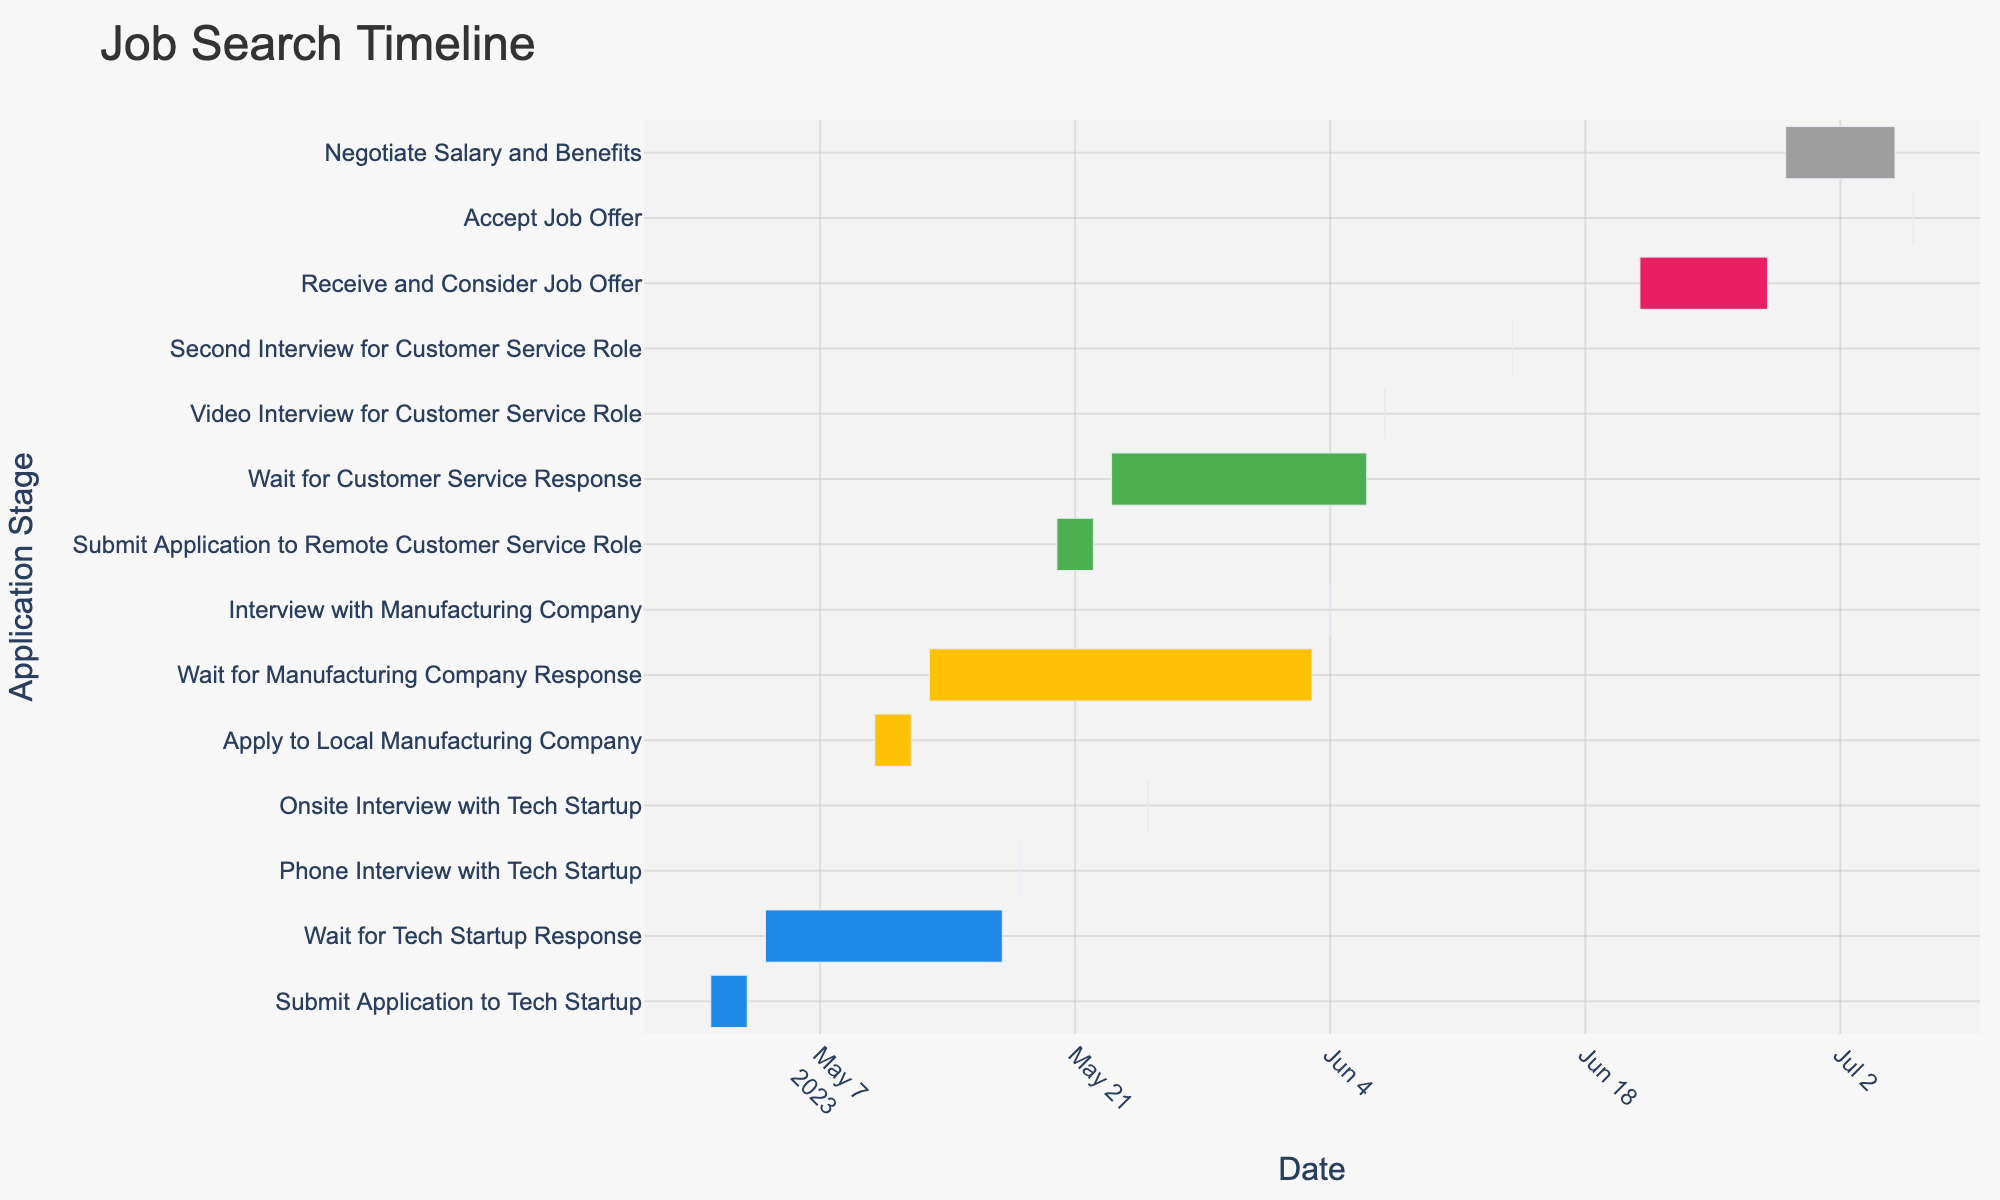What's the title of the figure? The title is usually located at the top of the figure. In this case, it is "Job Search Timeline."
Answer: Job Search Timeline What are the different job types represented in the figure? The job types can be inferred from the color legend and the tasks related to different industries. They are "Tech Startup," "Manufacturing Company," "Customer Service," and "Job Offer."
Answer: Tech Startup, Manufacturing Company, Customer Service, Job Offer How long did you wait for a response from the Tech Startup after applying? Look at the "Tech Startup" related tasks. The waiting period is from "2023-05-04" to "2023-05-17." Subtracting the start date from the end date gives 13 days.
Answer: 13 days Which job type had the most interview stages? Compare the interview stages for each job type. Customer Service has two interview stages: "Video Interview" and "Second Interview."
Answer: Customer Service What is the duration from the end of the application to receiving a response for the Remote Customer Service Role? For Customer Service, the application ends on "2023-05-22," and the response wait ends on "2023-06-06." Subtract the application end date from the response wait end date to get 15 days.
Answer: 15 days When did you have the onsite interview with the Tech Startup? Look for the "Onsite Interview with Tech Startup" task, which occurs on "2023-05-25."
Answer: 2023-05-25 How long did the entire job search process take, from the first application to accepting the job offer? The first application started on "2023-05-01," and the job offer was accepted on "2023-07-06." The duration is from May 1 to July 6, which is 67 days.
Answer: 67 days Which industry required the longest waiting time for a response? Compare the waiting periods: Tech Startup (13 days), Manufacturing Company (22 days), and Customer Service (15 days). The Manufacturing Company has the longest waiting time of 22 days.
Answer: Manufacturing Company What color represents Manufacturing Company tasks? Refer to the color used for Manufacturing Company-related tasks. It is yellow.
Answer: Yellow By how many days did the interview with the Manufacturing Company delay compared to the initial application with the Tech Startup? The Manufacturing Company interview was on "2023-06-04," and the first application to the Tech Startup started on "2023-05-01." The difference is 34 days.
Answer: 34 days 